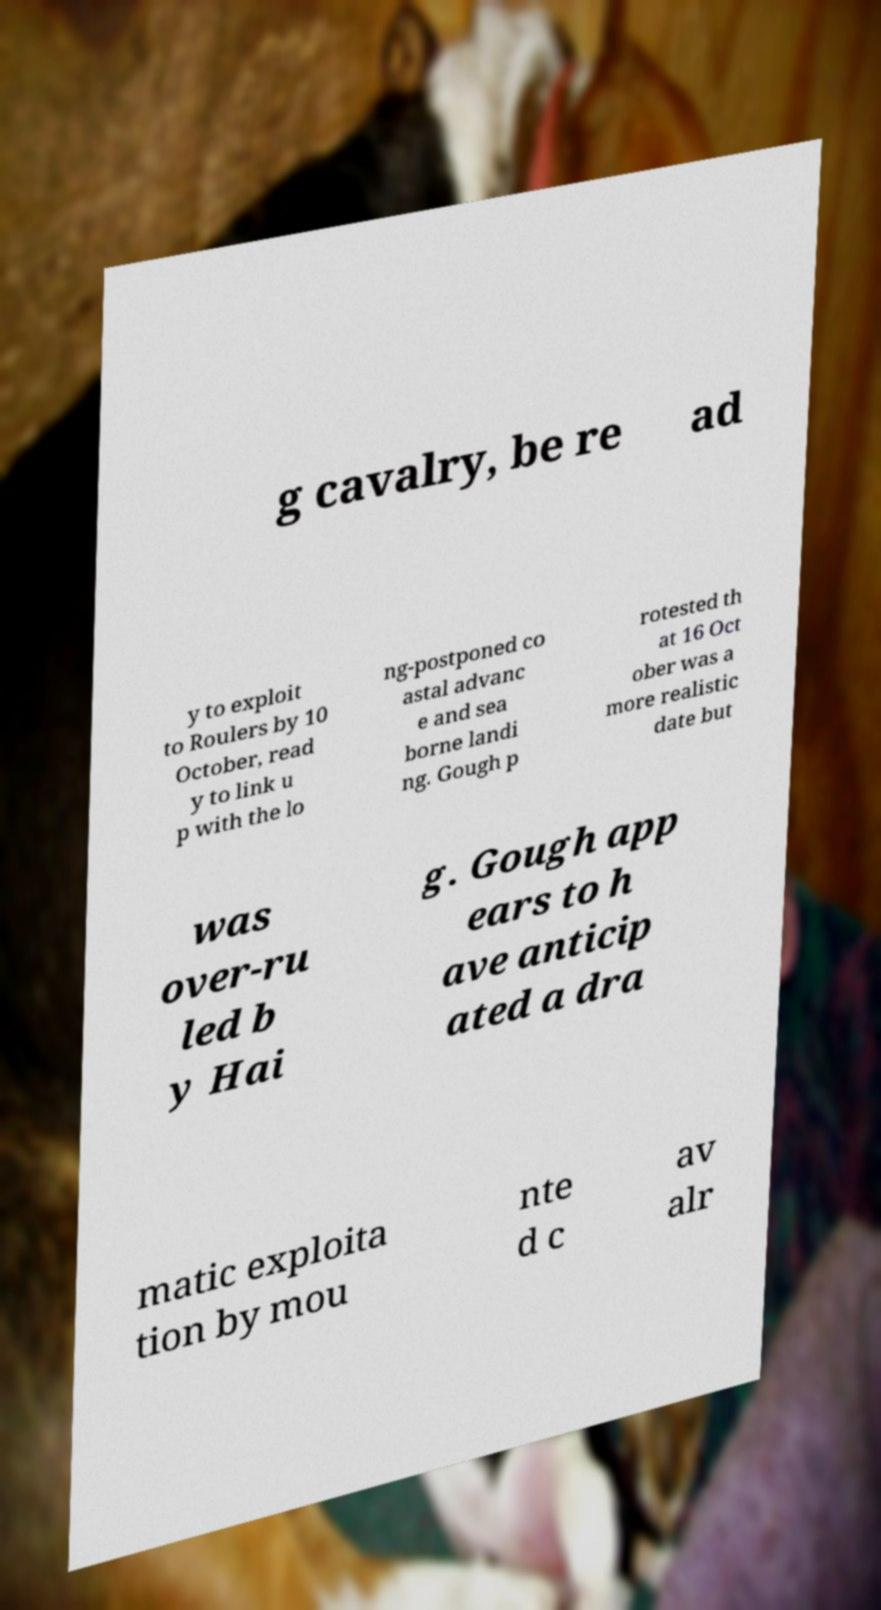What messages or text are displayed in this image? I need them in a readable, typed format. g cavalry, be re ad y to exploit to Roulers by 10 October, read y to link u p with the lo ng-postponed co astal advanc e and sea borne landi ng. Gough p rotested th at 16 Oct ober was a more realistic date but was over-ru led b y Hai g. Gough app ears to h ave anticip ated a dra matic exploita tion by mou nte d c av alr 